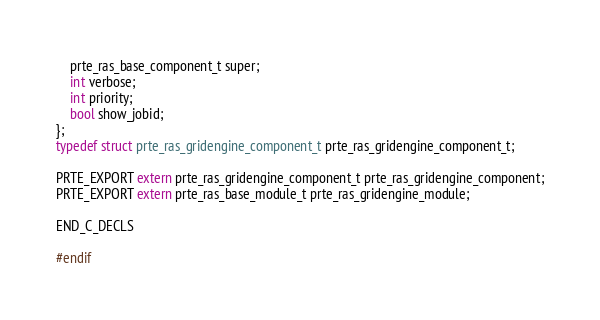<code> <loc_0><loc_0><loc_500><loc_500><_C_>    prte_ras_base_component_t super;
    int verbose;
    int priority;
    bool show_jobid;
};
typedef struct prte_ras_gridengine_component_t prte_ras_gridengine_component_t;

PRTE_EXPORT extern prte_ras_gridengine_component_t prte_ras_gridengine_component;
PRTE_EXPORT extern prte_ras_base_module_t prte_ras_gridengine_module;

END_C_DECLS

#endif
</code> 